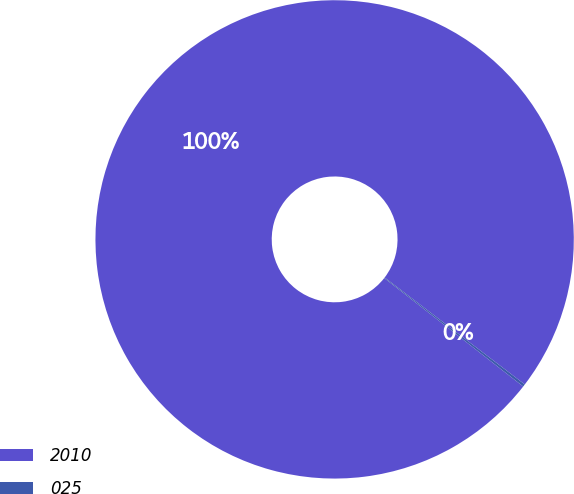<chart> <loc_0><loc_0><loc_500><loc_500><pie_chart><fcel>2010<fcel>025<nl><fcel>99.83%<fcel>0.17%<nl></chart> 